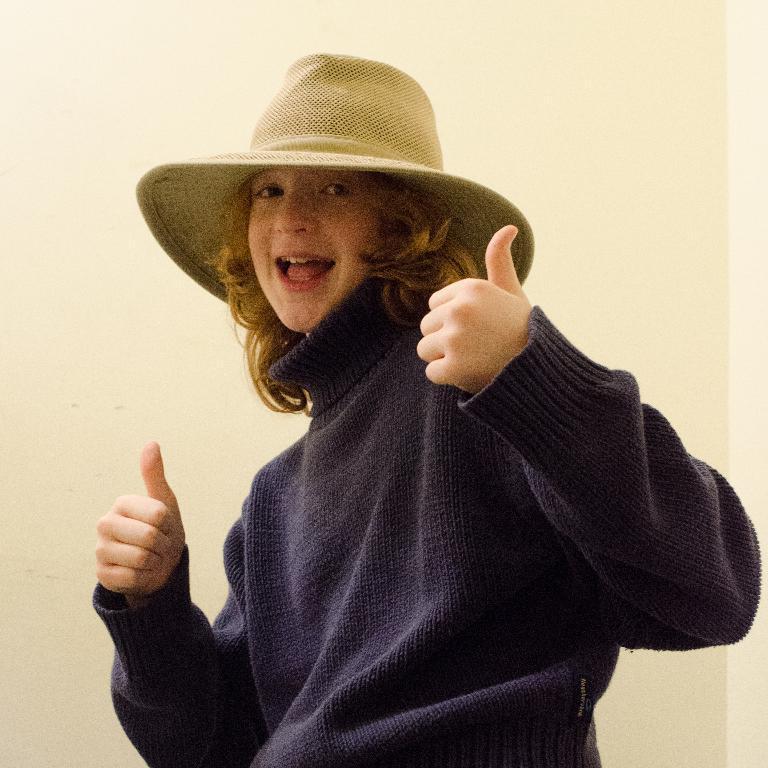How would you summarize this image in a sentence or two? In this picture I can see a woman, she is wearing a sweater and a hat. 